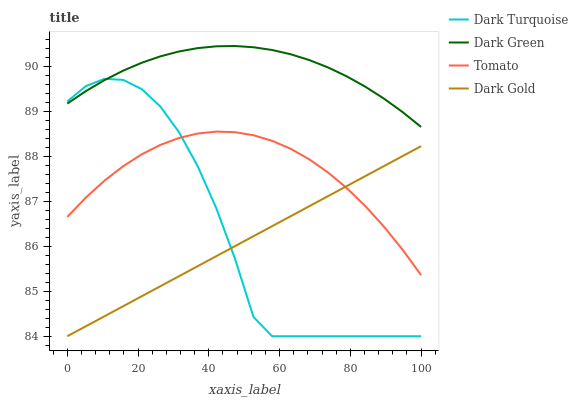Does Dark Gold have the minimum area under the curve?
Answer yes or no. Yes. Does Dark Green have the maximum area under the curve?
Answer yes or no. Yes. Does Dark Turquoise have the minimum area under the curve?
Answer yes or no. No. Does Dark Turquoise have the maximum area under the curve?
Answer yes or no. No. Is Dark Gold the smoothest?
Answer yes or no. Yes. Is Dark Turquoise the roughest?
Answer yes or no. Yes. Is Dark Turquoise the smoothest?
Answer yes or no. No. Is Dark Gold the roughest?
Answer yes or no. No. Does Dark Turquoise have the lowest value?
Answer yes or no. Yes. Does Dark Green have the lowest value?
Answer yes or no. No. Does Dark Green have the highest value?
Answer yes or no. Yes. Does Dark Turquoise have the highest value?
Answer yes or no. No. Is Dark Gold less than Dark Green?
Answer yes or no. Yes. Is Dark Green greater than Tomato?
Answer yes or no. Yes. Does Dark Gold intersect Tomato?
Answer yes or no. Yes. Is Dark Gold less than Tomato?
Answer yes or no. No. Is Dark Gold greater than Tomato?
Answer yes or no. No. Does Dark Gold intersect Dark Green?
Answer yes or no. No. 